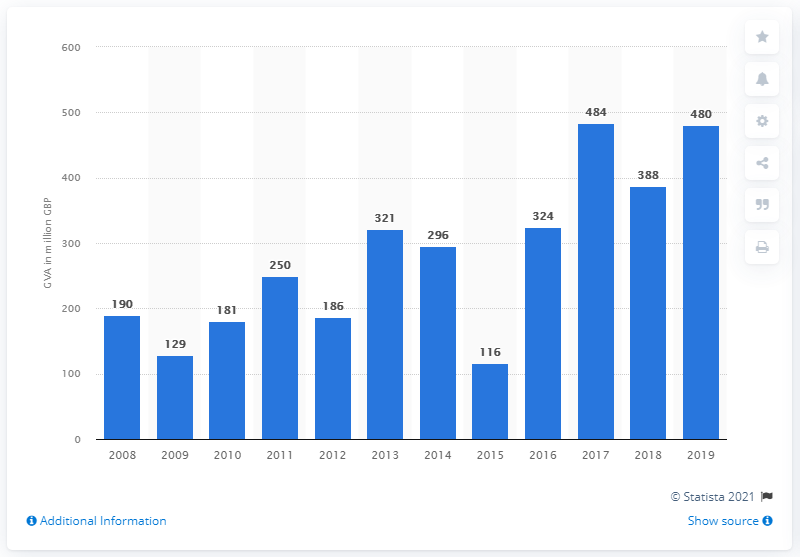Highlight a few significant elements in this photo. In 2019, aquaculture contributed approximately 480 million pounds to the Gross Value Added (GVA) of the UK Non-Financial Business Economy. 